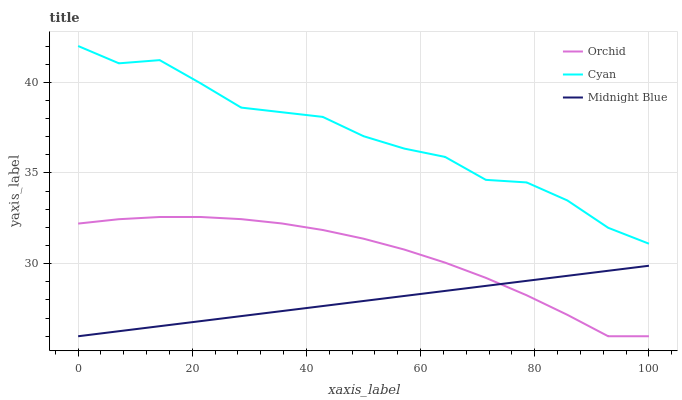Does Midnight Blue have the minimum area under the curve?
Answer yes or no. Yes. Does Cyan have the maximum area under the curve?
Answer yes or no. Yes. Does Orchid have the minimum area under the curve?
Answer yes or no. No. Does Orchid have the maximum area under the curve?
Answer yes or no. No. Is Midnight Blue the smoothest?
Answer yes or no. Yes. Is Cyan the roughest?
Answer yes or no. Yes. Is Orchid the smoothest?
Answer yes or no. No. Is Orchid the roughest?
Answer yes or no. No. Does Midnight Blue have the lowest value?
Answer yes or no. Yes. Does Cyan have the highest value?
Answer yes or no. Yes. Does Orchid have the highest value?
Answer yes or no. No. Is Orchid less than Cyan?
Answer yes or no. Yes. Is Cyan greater than Midnight Blue?
Answer yes or no. Yes. Does Orchid intersect Midnight Blue?
Answer yes or no. Yes. Is Orchid less than Midnight Blue?
Answer yes or no. No. Is Orchid greater than Midnight Blue?
Answer yes or no. No. Does Orchid intersect Cyan?
Answer yes or no. No. 